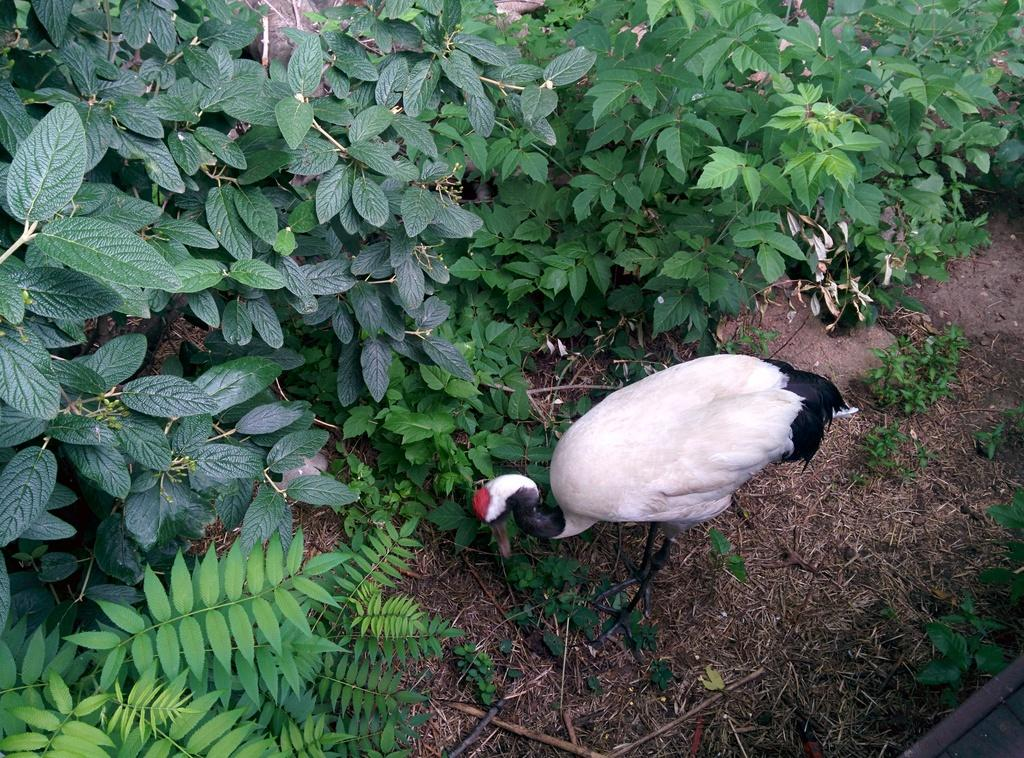What type of animal can be seen in the image? There is a bird in the image. What else is present in the image besides the bird? There are plants in the image. What type of horn can be seen on the bird in the image? There is no horn present on the bird in the image. How does the clam interact with the bird in the image? There is no clam present in the image, so it cannot interact with the bird. 